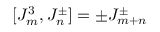Convert formula to latex. <formula><loc_0><loc_0><loc_500><loc_500>[ J _ { m } ^ { 3 } , J _ { n } ^ { \pm } ] = \pm J _ { m + n } ^ { \pm }</formula> 